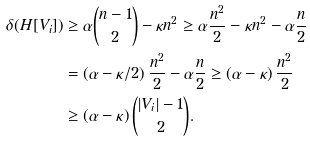<formula> <loc_0><loc_0><loc_500><loc_500>\delta ( H [ V _ { i } ] ) & \geq \alpha \binom { n - 1 } { 2 } - \kappa n ^ { 2 } \geq \alpha \frac { n ^ { 2 } } { 2 } - \kappa n ^ { 2 } - \alpha \frac { n } { 2 } \\ & = \left ( \alpha - \kappa / 2 \right ) \frac { n ^ { 2 } } { 2 } - \alpha \frac { n } { 2 } \geq \left ( \alpha - \kappa \right ) \frac { n ^ { 2 } } { 2 } \\ & \geq \left ( \alpha - \kappa \right ) \binom { | V _ { i } | - 1 } { 2 } .</formula> 